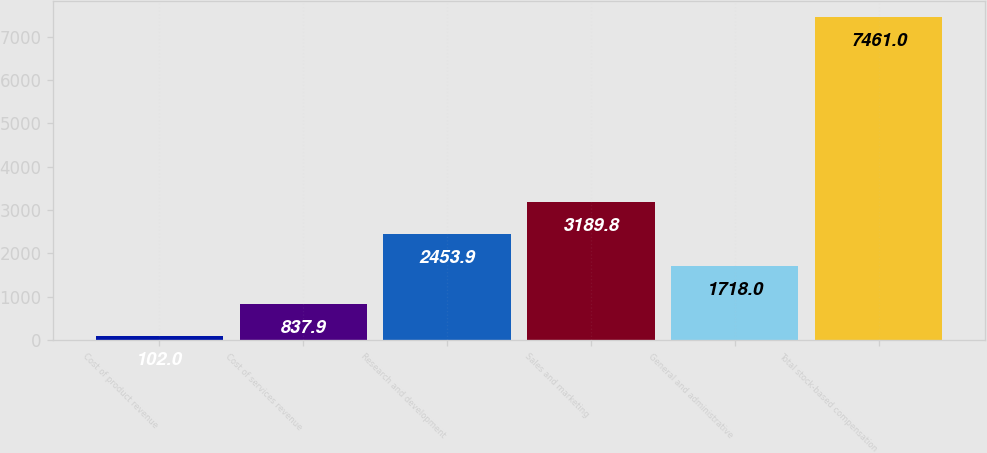Convert chart. <chart><loc_0><loc_0><loc_500><loc_500><bar_chart><fcel>Cost of product revenue<fcel>Cost of services revenue<fcel>Research and development<fcel>Sales and marketing<fcel>General and administrative<fcel>Total stock-based compensation<nl><fcel>102<fcel>837.9<fcel>2453.9<fcel>3189.8<fcel>1718<fcel>7461<nl></chart> 